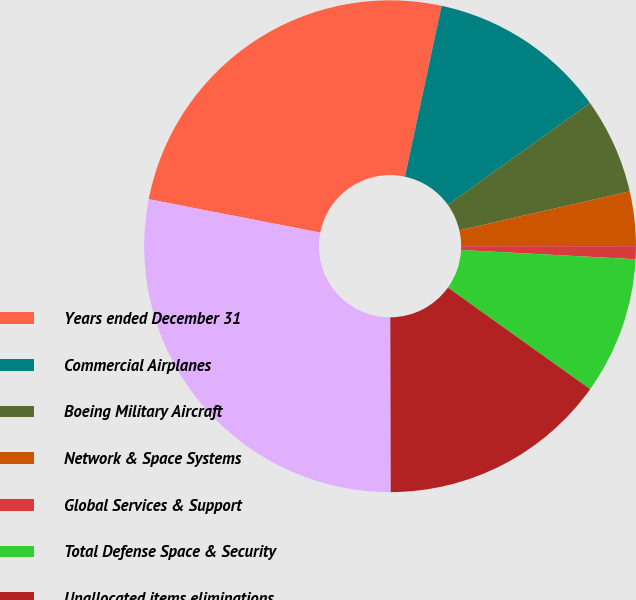Convert chart. <chart><loc_0><loc_0><loc_500><loc_500><pie_chart><fcel>Years ended December 31<fcel>Commercial Airplanes<fcel>Boeing Military Aircraft<fcel>Network & Space Systems<fcel>Global Services & Support<fcel>Total Defense Space & Security<fcel>Unallocated items eliminations<fcel>Total<nl><fcel>25.3%<fcel>11.75%<fcel>6.3%<fcel>3.58%<fcel>0.85%<fcel>9.03%<fcel>15.1%<fcel>28.09%<nl></chart> 